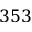Convert formula to latex. <formula><loc_0><loc_0><loc_500><loc_500>3 5 3</formula> 